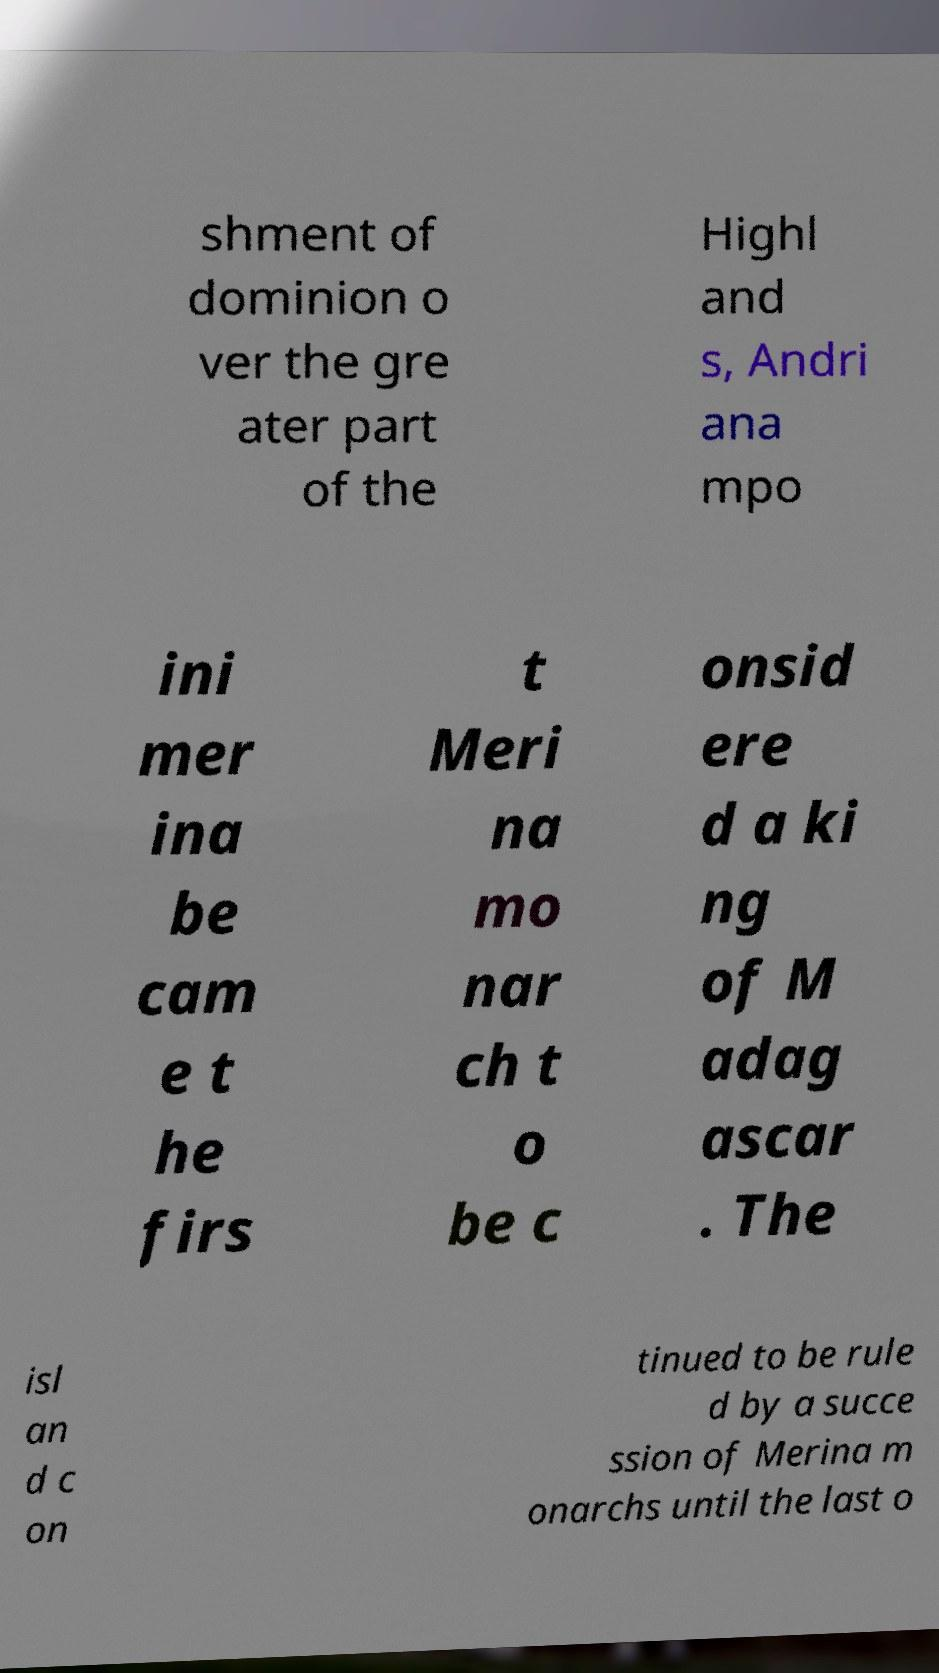Can you read and provide the text displayed in the image?This photo seems to have some interesting text. Can you extract and type it out for me? shment of dominion o ver the gre ater part of the Highl and s, Andri ana mpo ini mer ina be cam e t he firs t Meri na mo nar ch t o be c onsid ere d a ki ng of M adag ascar . The isl an d c on tinued to be rule d by a succe ssion of Merina m onarchs until the last o 